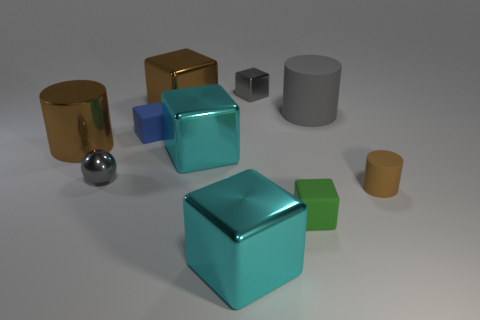Can you describe the arrangement and colors of the objects shown? Certainly! In the image, we have a variety of geometric objects arrayed against a neutral background. There's a prominent cyan cube at the center, and behind it, there's a gray cylindrical object. To its left, we see two more objects: a brown metallic cylinder and a smaller gold cube. On the far right, there's an amber cylindrical object. In front of the central cyan cube, there's a small green cube and a silver spherical object, adding a touch of variety to the shapes presented. 